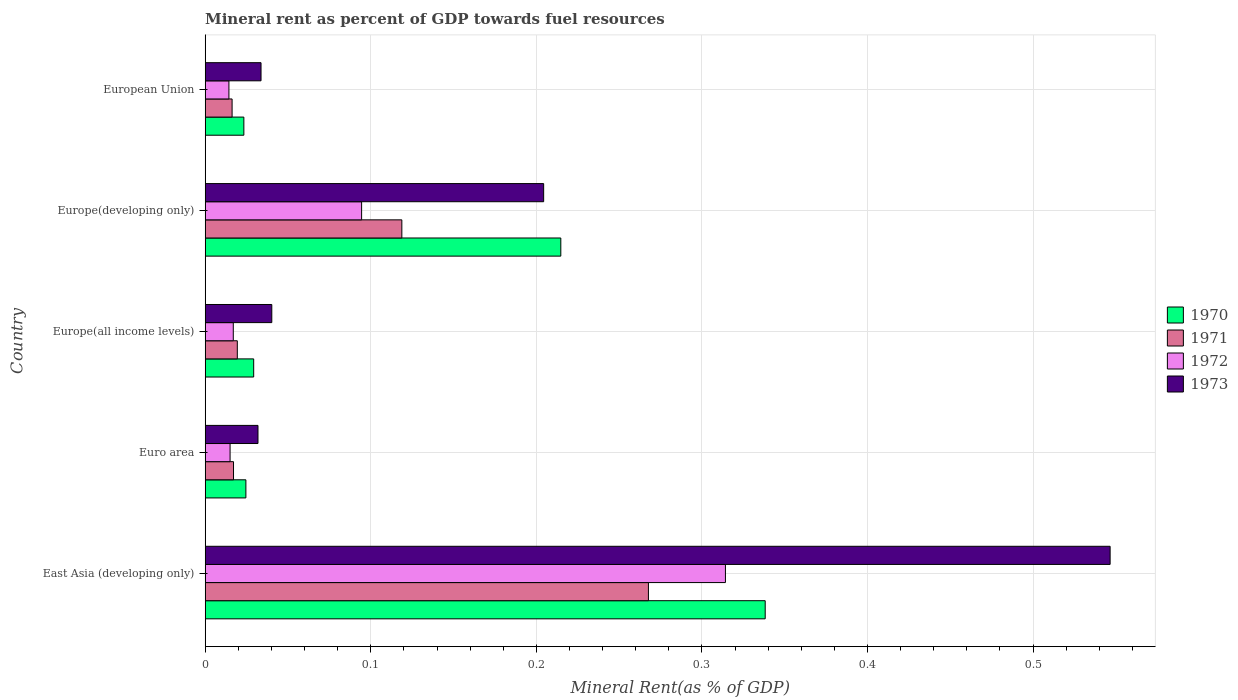How many different coloured bars are there?
Give a very brief answer. 4. Are the number of bars on each tick of the Y-axis equal?
Make the answer very short. Yes. In how many cases, is the number of bars for a given country not equal to the number of legend labels?
Offer a very short reply. 0. What is the mineral rent in 1972 in Europe(all income levels)?
Keep it short and to the point. 0.02. Across all countries, what is the maximum mineral rent in 1971?
Provide a succinct answer. 0.27. Across all countries, what is the minimum mineral rent in 1970?
Offer a very short reply. 0.02. In which country was the mineral rent in 1972 maximum?
Provide a succinct answer. East Asia (developing only). What is the total mineral rent in 1973 in the graph?
Provide a short and direct response. 0.86. What is the difference between the mineral rent in 1973 in Euro area and that in Europe(all income levels)?
Your response must be concise. -0.01. What is the difference between the mineral rent in 1973 in European Union and the mineral rent in 1971 in Europe(all income levels)?
Offer a terse response. 0.01. What is the average mineral rent in 1973 per country?
Give a very brief answer. 0.17. What is the difference between the mineral rent in 1972 and mineral rent in 1973 in European Union?
Keep it short and to the point. -0.02. In how many countries, is the mineral rent in 1972 greater than 0.38000000000000006 %?
Make the answer very short. 0. What is the ratio of the mineral rent in 1973 in Euro area to that in European Union?
Offer a terse response. 0.95. Is the difference between the mineral rent in 1972 in East Asia (developing only) and European Union greater than the difference between the mineral rent in 1973 in East Asia (developing only) and European Union?
Make the answer very short. No. What is the difference between the highest and the second highest mineral rent in 1970?
Your response must be concise. 0.12. What is the difference between the highest and the lowest mineral rent in 1972?
Provide a succinct answer. 0.3. Is the sum of the mineral rent in 1971 in East Asia (developing only) and Europe(developing only) greater than the maximum mineral rent in 1972 across all countries?
Keep it short and to the point. Yes. Is it the case that in every country, the sum of the mineral rent in 1970 and mineral rent in 1971 is greater than the sum of mineral rent in 1973 and mineral rent in 1972?
Ensure brevity in your answer.  No. What does the 2nd bar from the bottom in Europe(all income levels) represents?
Give a very brief answer. 1971. Is it the case that in every country, the sum of the mineral rent in 1970 and mineral rent in 1971 is greater than the mineral rent in 1972?
Give a very brief answer. Yes. How many countries are there in the graph?
Your answer should be very brief. 5. What is the difference between two consecutive major ticks on the X-axis?
Keep it short and to the point. 0.1. Where does the legend appear in the graph?
Your answer should be very brief. Center right. What is the title of the graph?
Ensure brevity in your answer.  Mineral rent as percent of GDP towards fuel resources. What is the label or title of the X-axis?
Offer a terse response. Mineral Rent(as % of GDP). What is the Mineral Rent(as % of GDP) of 1970 in East Asia (developing only)?
Offer a terse response. 0.34. What is the Mineral Rent(as % of GDP) of 1971 in East Asia (developing only)?
Keep it short and to the point. 0.27. What is the Mineral Rent(as % of GDP) of 1972 in East Asia (developing only)?
Offer a very short reply. 0.31. What is the Mineral Rent(as % of GDP) of 1973 in East Asia (developing only)?
Keep it short and to the point. 0.55. What is the Mineral Rent(as % of GDP) of 1970 in Euro area?
Provide a short and direct response. 0.02. What is the Mineral Rent(as % of GDP) in 1971 in Euro area?
Give a very brief answer. 0.02. What is the Mineral Rent(as % of GDP) in 1972 in Euro area?
Provide a succinct answer. 0.02. What is the Mineral Rent(as % of GDP) of 1973 in Euro area?
Ensure brevity in your answer.  0.03. What is the Mineral Rent(as % of GDP) in 1970 in Europe(all income levels)?
Offer a terse response. 0.03. What is the Mineral Rent(as % of GDP) of 1971 in Europe(all income levels)?
Provide a succinct answer. 0.02. What is the Mineral Rent(as % of GDP) in 1972 in Europe(all income levels)?
Provide a short and direct response. 0.02. What is the Mineral Rent(as % of GDP) of 1973 in Europe(all income levels)?
Give a very brief answer. 0.04. What is the Mineral Rent(as % of GDP) of 1970 in Europe(developing only)?
Ensure brevity in your answer.  0.21. What is the Mineral Rent(as % of GDP) in 1971 in Europe(developing only)?
Give a very brief answer. 0.12. What is the Mineral Rent(as % of GDP) of 1972 in Europe(developing only)?
Provide a succinct answer. 0.09. What is the Mineral Rent(as % of GDP) of 1973 in Europe(developing only)?
Your answer should be compact. 0.2. What is the Mineral Rent(as % of GDP) in 1970 in European Union?
Your answer should be compact. 0.02. What is the Mineral Rent(as % of GDP) in 1971 in European Union?
Offer a very short reply. 0.02. What is the Mineral Rent(as % of GDP) in 1972 in European Union?
Provide a short and direct response. 0.01. What is the Mineral Rent(as % of GDP) in 1973 in European Union?
Your answer should be very brief. 0.03. Across all countries, what is the maximum Mineral Rent(as % of GDP) of 1970?
Offer a very short reply. 0.34. Across all countries, what is the maximum Mineral Rent(as % of GDP) of 1971?
Make the answer very short. 0.27. Across all countries, what is the maximum Mineral Rent(as % of GDP) in 1972?
Offer a very short reply. 0.31. Across all countries, what is the maximum Mineral Rent(as % of GDP) of 1973?
Your response must be concise. 0.55. Across all countries, what is the minimum Mineral Rent(as % of GDP) of 1970?
Offer a terse response. 0.02. Across all countries, what is the minimum Mineral Rent(as % of GDP) of 1971?
Keep it short and to the point. 0.02. Across all countries, what is the minimum Mineral Rent(as % of GDP) in 1972?
Provide a succinct answer. 0.01. Across all countries, what is the minimum Mineral Rent(as % of GDP) in 1973?
Give a very brief answer. 0.03. What is the total Mineral Rent(as % of GDP) in 1970 in the graph?
Provide a short and direct response. 0.63. What is the total Mineral Rent(as % of GDP) in 1971 in the graph?
Provide a short and direct response. 0.44. What is the total Mineral Rent(as % of GDP) of 1972 in the graph?
Offer a terse response. 0.46. What is the total Mineral Rent(as % of GDP) of 1973 in the graph?
Your answer should be very brief. 0.86. What is the difference between the Mineral Rent(as % of GDP) in 1970 in East Asia (developing only) and that in Euro area?
Ensure brevity in your answer.  0.31. What is the difference between the Mineral Rent(as % of GDP) of 1971 in East Asia (developing only) and that in Euro area?
Provide a succinct answer. 0.25. What is the difference between the Mineral Rent(as % of GDP) of 1972 in East Asia (developing only) and that in Euro area?
Offer a very short reply. 0.3. What is the difference between the Mineral Rent(as % of GDP) of 1973 in East Asia (developing only) and that in Euro area?
Provide a succinct answer. 0.51. What is the difference between the Mineral Rent(as % of GDP) of 1970 in East Asia (developing only) and that in Europe(all income levels)?
Your response must be concise. 0.31. What is the difference between the Mineral Rent(as % of GDP) of 1971 in East Asia (developing only) and that in Europe(all income levels)?
Give a very brief answer. 0.25. What is the difference between the Mineral Rent(as % of GDP) of 1972 in East Asia (developing only) and that in Europe(all income levels)?
Provide a succinct answer. 0.3. What is the difference between the Mineral Rent(as % of GDP) of 1973 in East Asia (developing only) and that in Europe(all income levels)?
Your answer should be compact. 0.51. What is the difference between the Mineral Rent(as % of GDP) in 1970 in East Asia (developing only) and that in Europe(developing only)?
Your answer should be very brief. 0.12. What is the difference between the Mineral Rent(as % of GDP) in 1971 in East Asia (developing only) and that in Europe(developing only)?
Offer a very short reply. 0.15. What is the difference between the Mineral Rent(as % of GDP) of 1972 in East Asia (developing only) and that in Europe(developing only)?
Make the answer very short. 0.22. What is the difference between the Mineral Rent(as % of GDP) of 1973 in East Asia (developing only) and that in Europe(developing only)?
Provide a succinct answer. 0.34. What is the difference between the Mineral Rent(as % of GDP) in 1970 in East Asia (developing only) and that in European Union?
Your response must be concise. 0.31. What is the difference between the Mineral Rent(as % of GDP) in 1971 in East Asia (developing only) and that in European Union?
Make the answer very short. 0.25. What is the difference between the Mineral Rent(as % of GDP) in 1972 in East Asia (developing only) and that in European Union?
Your answer should be very brief. 0.3. What is the difference between the Mineral Rent(as % of GDP) of 1973 in East Asia (developing only) and that in European Union?
Your answer should be very brief. 0.51. What is the difference between the Mineral Rent(as % of GDP) of 1970 in Euro area and that in Europe(all income levels)?
Your answer should be compact. -0. What is the difference between the Mineral Rent(as % of GDP) in 1971 in Euro area and that in Europe(all income levels)?
Provide a succinct answer. -0. What is the difference between the Mineral Rent(as % of GDP) in 1972 in Euro area and that in Europe(all income levels)?
Offer a very short reply. -0. What is the difference between the Mineral Rent(as % of GDP) in 1973 in Euro area and that in Europe(all income levels)?
Offer a very short reply. -0.01. What is the difference between the Mineral Rent(as % of GDP) of 1970 in Euro area and that in Europe(developing only)?
Your answer should be compact. -0.19. What is the difference between the Mineral Rent(as % of GDP) in 1971 in Euro area and that in Europe(developing only)?
Offer a terse response. -0.1. What is the difference between the Mineral Rent(as % of GDP) in 1972 in Euro area and that in Europe(developing only)?
Keep it short and to the point. -0.08. What is the difference between the Mineral Rent(as % of GDP) in 1973 in Euro area and that in Europe(developing only)?
Keep it short and to the point. -0.17. What is the difference between the Mineral Rent(as % of GDP) in 1970 in Euro area and that in European Union?
Ensure brevity in your answer.  0. What is the difference between the Mineral Rent(as % of GDP) of 1971 in Euro area and that in European Union?
Ensure brevity in your answer.  0. What is the difference between the Mineral Rent(as % of GDP) in 1972 in Euro area and that in European Union?
Make the answer very short. 0. What is the difference between the Mineral Rent(as % of GDP) of 1973 in Euro area and that in European Union?
Make the answer very short. -0. What is the difference between the Mineral Rent(as % of GDP) in 1970 in Europe(all income levels) and that in Europe(developing only)?
Provide a short and direct response. -0.19. What is the difference between the Mineral Rent(as % of GDP) of 1971 in Europe(all income levels) and that in Europe(developing only)?
Your answer should be very brief. -0.1. What is the difference between the Mineral Rent(as % of GDP) of 1972 in Europe(all income levels) and that in Europe(developing only)?
Ensure brevity in your answer.  -0.08. What is the difference between the Mineral Rent(as % of GDP) in 1973 in Europe(all income levels) and that in Europe(developing only)?
Offer a terse response. -0.16. What is the difference between the Mineral Rent(as % of GDP) of 1970 in Europe(all income levels) and that in European Union?
Offer a terse response. 0.01. What is the difference between the Mineral Rent(as % of GDP) in 1971 in Europe(all income levels) and that in European Union?
Make the answer very short. 0. What is the difference between the Mineral Rent(as % of GDP) of 1972 in Europe(all income levels) and that in European Union?
Your answer should be very brief. 0. What is the difference between the Mineral Rent(as % of GDP) in 1973 in Europe(all income levels) and that in European Union?
Provide a succinct answer. 0.01. What is the difference between the Mineral Rent(as % of GDP) in 1970 in Europe(developing only) and that in European Union?
Provide a short and direct response. 0.19. What is the difference between the Mineral Rent(as % of GDP) of 1971 in Europe(developing only) and that in European Union?
Provide a succinct answer. 0.1. What is the difference between the Mineral Rent(as % of GDP) in 1972 in Europe(developing only) and that in European Union?
Your answer should be very brief. 0.08. What is the difference between the Mineral Rent(as % of GDP) in 1973 in Europe(developing only) and that in European Union?
Ensure brevity in your answer.  0.17. What is the difference between the Mineral Rent(as % of GDP) in 1970 in East Asia (developing only) and the Mineral Rent(as % of GDP) in 1971 in Euro area?
Provide a succinct answer. 0.32. What is the difference between the Mineral Rent(as % of GDP) of 1970 in East Asia (developing only) and the Mineral Rent(as % of GDP) of 1972 in Euro area?
Keep it short and to the point. 0.32. What is the difference between the Mineral Rent(as % of GDP) in 1970 in East Asia (developing only) and the Mineral Rent(as % of GDP) in 1973 in Euro area?
Make the answer very short. 0.31. What is the difference between the Mineral Rent(as % of GDP) of 1971 in East Asia (developing only) and the Mineral Rent(as % of GDP) of 1972 in Euro area?
Provide a short and direct response. 0.25. What is the difference between the Mineral Rent(as % of GDP) in 1971 in East Asia (developing only) and the Mineral Rent(as % of GDP) in 1973 in Euro area?
Provide a succinct answer. 0.24. What is the difference between the Mineral Rent(as % of GDP) of 1972 in East Asia (developing only) and the Mineral Rent(as % of GDP) of 1973 in Euro area?
Provide a short and direct response. 0.28. What is the difference between the Mineral Rent(as % of GDP) of 1970 in East Asia (developing only) and the Mineral Rent(as % of GDP) of 1971 in Europe(all income levels)?
Your response must be concise. 0.32. What is the difference between the Mineral Rent(as % of GDP) in 1970 in East Asia (developing only) and the Mineral Rent(as % of GDP) in 1972 in Europe(all income levels)?
Offer a very short reply. 0.32. What is the difference between the Mineral Rent(as % of GDP) of 1970 in East Asia (developing only) and the Mineral Rent(as % of GDP) of 1973 in Europe(all income levels)?
Ensure brevity in your answer.  0.3. What is the difference between the Mineral Rent(as % of GDP) of 1971 in East Asia (developing only) and the Mineral Rent(as % of GDP) of 1972 in Europe(all income levels)?
Give a very brief answer. 0.25. What is the difference between the Mineral Rent(as % of GDP) of 1971 in East Asia (developing only) and the Mineral Rent(as % of GDP) of 1973 in Europe(all income levels)?
Make the answer very short. 0.23. What is the difference between the Mineral Rent(as % of GDP) of 1972 in East Asia (developing only) and the Mineral Rent(as % of GDP) of 1973 in Europe(all income levels)?
Give a very brief answer. 0.27. What is the difference between the Mineral Rent(as % of GDP) in 1970 in East Asia (developing only) and the Mineral Rent(as % of GDP) in 1971 in Europe(developing only)?
Your answer should be compact. 0.22. What is the difference between the Mineral Rent(as % of GDP) in 1970 in East Asia (developing only) and the Mineral Rent(as % of GDP) in 1972 in Europe(developing only)?
Give a very brief answer. 0.24. What is the difference between the Mineral Rent(as % of GDP) of 1970 in East Asia (developing only) and the Mineral Rent(as % of GDP) of 1973 in Europe(developing only)?
Your answer should be very brief. 0.13. What is the difference between the Mineral Rent(as % of GDP) of 1971 in East Asia (developing only) and the Mineral Rent(as % of GDP) of 1972 in Europe(developing only)?
Provide a short and direct response. 0.17. What is the difference between the Mineral Rent(as % of GDP) of 1971 in East Asia (developing only) and the Mineral Rent(as % of GDP) of 1973 in Europe(developing only)?
Make the answer very short. 0.06. What is the difference between the Mineral Rent(as % of GDP) of 1972 in East Asia (developing only) and the Mineral Rent(as % of GDP) of 1973 in Europe(developing only)?
Offer a very short reply. 0.11. What is the difference between the Mineral Rent(as % of GDP) of 1970 in East Asia (developing only) and the Mineral Rent(as % of GDP) of 1971 in European Union?
Your answer should be very brief. 0.32. What is the difference between the Mineral Rent(as % of GDP) of 1970 in East Asia (developing only) and the Mineral Rent(as % of GDP) of 1972 in European Union?
Provide a succinct answer. 0.32. What is the difference between the Mineral Rent(as % of GDP) in 1970 in East Asia (developing only) and the Mineral Rent(as % of GDP) in 1973 in European Union?
Offer a terse response. 0.3. What is the difference between the Mineral Rent(as % of GDP) in 1971 in East Asia (developing only) and the Mineral Rent(as % of GDP) in 1972 in European Union?
Provide a short and direct response. 0.25. What is the difference between the Mineral Rent(as % of GDP) in 1971 in East Asia (developing only) and the Mineral Rent(as % of GDP) in 1973 in European Union?
Ensure brevity in your answer.  0.23. What is the difference between the Mineral Rent(as % of GDP) of 1972 in East Asia (developing only) and the Mineral Rent(as % of GDP) of 1973 in European Union?
Make the answer very short. 0.28. What is the difference between the Mineral Rent(as % of GDP) of 1970 in Euro area and the Mineral Rent(as % of GDP) of 1971 in Europe(all income levels)?
Offer a very short reply. 0.01. What is the difference between the Mineral Rent(as % of GDP) in 1970 in Euro area and the Mineral Rent(as % of GDP) in 1972 in Europe(all income levels)?
Give a very brief answer. 0.01. What is the difference between the Mineral Rent(as % of GDP) of 1970 in Euro area and the Mineral Rent(as % of GDP) of 1973 in Europe(all income levels)?
Provide a succinct answer. -0.02. What is the difference between the Mineral Rent(as % of GDP) of 1971 in Euro area and the Mineral Rent(as % of GDP) of 1972 in Europe(all income levels)?
Provide a short and direct response. 0. What is the difference between the Mineral Rent(as % of GDP) in 1971 in Euro area and the Mineral Rent(as % of GDP) in 1973 in Europe(all income levels)?
Provide a succinct answer. -0.02. What is the difference between the Mineral Rent(as % of GDP) in 1972 in Euro area and the Mineral Rent(as % of GDP) in 1973 in Europe(all income levels)?
Give a very brief answer. -0.03. What is the difference between the Mineral Rent(as % of GDP) in 1970 in Euro area and the Mineral Rent(as % of GDP) in 1971 in Europe(developing only)?
Offer a very short reply. -0.09. What is the difference between the Mineral Rent(as % of GDP) in 1970 in Euro area and the Mineral Rent(as % of GDP) in 1972 in Europe(developing only)?
Offer a terse response. -0.07. What is the difference between the Mineral Rent(as % of GDP) of 1970 in Euro area and the Mineral Rent(as % of GDP) of 1973 in Europe(developing only)?
Provide a succinct answer. -0.18. What is the difference between the Mineral Rent(as % of GDP) in 1971 in Euro area and the Mineral Rent(as % of GDP) in 1972 in Europe(developing only)?
Provide a succinct answer. -0.08. What is the difference between the Mineral Rent(as % of GDP) of 1971 in Euro area and the Mineral Rent(as % of GDP) of 1973 in Europe(developing only)?
Offer a very short reply. -0.19. What is the difference between the Mineral Rent(as % of GDP) of 1972 in Euro area and the Mineral Rent(as % of GDP) of 1973 in Europe(developing only)?
Offer a terse response. -0.19. What is the difference between the Mineral Rent(as % of GDP) of 1970 in Euro area and the Mineral Rent(as % of GDP) of 1971 in European Union?
Your response must be concise. 0.01. What is the difference between the Mineral Rent(as % of GDP) in 1970 in Euro area and the Mineral Rent(as % of GDP) in 1972 in European Union?
Your answer should be compact. 0.01. What is the difference between the Mineral Rent(as % of GDP) in 1970 in Euro area and the Mineral Rent(as % of GDP) in 1973 in European Union?
Offer a terse response. -0.01. What is the difference between the Mineral Rent(as % of GDP) in 1971 in Euro area and the Mineral Rent(as % of GDP) in 1972 in European Union?
Offer a terse response. 0. What is the difference between the Mineral Rent(as % of GDP) of 1971 in Euro area and the Mineral Rent(as % of GDP) of 1973 in European Union?
Your response must be concise. -0.02. What is the difference between the Mineral Rent(as % of GDP) of 1972 in Euro area and the Mineral Rent(as % of GDP) of 1973 in European Union?
Ensure brevity in your answer.  -0.02. What is the difference between the Mineral Rent(as % of GDP) in 1970 in Europe(all income levels) and the Mineral Rent(as % of GDP) in 1971 in Europe(developing only)?
Your answer should be compact. -0.09. What is the difference between the Mineral Rent(as % of GDP) of 1970 in Europe(all income levels) and the Mineral Rent(as % of GDP) of 1972 in Europe(developing only)?
Provide a short and direct response. -0.07. What is the difference between the Mineral Rent(as % of GDP) of 1970 in Europe(all income levels) and the Mineral Rent(as % of GDP) of 1973 in Europe(developing only)?
Make the answer very short. -0.18. What is the difference between the Mineral Rent(as % of GDP) in 1971 in Europe(all income levels) and the Mineral Rent(as % of GDP) in 1972 in Europe(developing only)?
Your answer should be very brief. -0.08. What is the difference between the Mineral Rent(as % of GDP) of 1971 in Europe(all income levels) and the Mineral Rent(as % of GDP) of 1973 in Europe(developing only)?
Your answer should be very brief. -0.18. What is the difference between the Mineral Rent(as % of GDP) in 1972 in Europe(all income levels) and the Mineral Rent(as % of GDP) in 1973 in Europe(developing only)?
Give a very brief answer. -0.19. What is the difference between the Mineral Rent(as % of GDP) of 1970 in Europe(all income levels) and the Mineral Rent(as % of GDP) of 1971 in European Union?
Offer a terse response. 0.01. What is the difference between the Mineral Rent(as % of GDP) in 1970 in Europe(all income levels) and the Mineral Rent(as % of GDP) in 1972 in European Union?
Your response must be concise. 0.01. What is the difference between the Mineral Rent(as % of GDP) of 1970 in Europe(all income levels) and the Mineral Rent(as % of GDP) of 1973 in European Union?
Give a very brief answer. -0. What is the difference between the Mineral Rent(as % of GDP) of 1971 in Europe(all income levels) and the Mineral Rent(as % of GDP) of 1972 in European Union?
Offer a very short reply. 0.01. What is the difference between the Mineral Rent(as % of GDP) in 1971 in Europe(all income levels) and the Mineral Rent(as % of GDP) in 1973 in European Union?
Make the answer very short. -0.01. What is the difference between the Mineral Rent(as % of GDP) of 1972 in Europe(all income levels) and the Mineral Rent(as % of GDP) of 1973 in European Union?
Ensure brevity in your answer.  -0.02. What is the difference between the Mineral Rent(as % of GDP) in 1970 in Europe(developing only) and the Mineral Rent(as % of GDP) in 1971 in European Union?
Offer a terse response. 0.2. What is the difference between the Mineral Rent(as % of GDP) of 1970 in Europe(developing only) and the Mineral Rent(as % of GDP) of 1972 in European Union?
Give a very brief answer. 0.2. What is the difference between the Mineral Rent(as % of GDP) in 1970 in Europe(developing only) and the Mineral Rent(as % of GDP) in 1973 in European Union?
Make the answer very short. 0.18. What is the difference between the Mineral Rent(as % of GDP) in 1971 in Europe(developing only) and the Mineral Rent(as % of GDP) in 1972 in European Union?
Make the answer very short. 0.1. What is the difference between the Mineral Rent(as % of GDP) in 1971 in Europe(developing only) and the Mineral Rent(as % of GDP) in 1973 in European Union?
Your response must be concise. 0.09. What is the difference between the Mineral Rent(as % of GDP) in 1972 in Europe(developing only) and the Mineral Rent(as % of GDP) in 1973 in European Union?
Make the answer very short. 0.06. What is the average Mineral Rent(as % of GDP) of 1970 per country?
Offer a very short reply. 0.13. What is the average Mineral Rent(as % of GDP) of 1971 per country?
Ensure brevity in your answer.  0.09. What is the average Mineral Rent(as % of GDP) in 1972 per country?
Offer a terse response. 0.09. What is the average Mineral Rent(as % of GDP) in 1973 per country?
Give a very brief answer. 0.17. What is the difference between the Mineral Rent(as % of GDP) in 1970 and Mineral Rent(as % of GDP) in 1971 in East Asia (developing only)?
Offer a very short reply. 0.07. What is the difference between the Mineral Rent(as % of GDP) of 1970 and Mineral Rent(as % of GDP) of 1972 in East Asia (developing only)?
Give a very brief answer. 0.02. What is the difference between the Mineral Rent(as % of GDP) in 1970 and Mineral Rent(as % of GDP) in 1973 in East Asia (developing only)?
Offer a terse response. -0.21. What is the difference between the Mineral Rent(as % of GDP) in 1971 and Mineral Rent(as % of GDP) in 1972 in East Asia (developing only)?
Offer a very short reply. -0.05. What is the difference between the Mineral Rent(as % of GDP) of 1971 and Mineral Rent(as % of GDP) of 1973 in East Asia (developing only)?
Your answer should be compact. -0.28. What is the difference between the Mineral Rent(as % of GDP) in 1972 and Mineral Rent(as % of GDP) in 1973 in East Asia (developing only)?
Give a very brief answer. -0.23. What is the difference between the Mineral Rent(as % of GDP) in 1970 and Mineral Rent(as % of GDP) in 1971 in Euro area?
Offer a very short reply. 0.01. What is the difference between the Mineral Rent(as % of GDP) in 1970 and Mineral Rent(as % of GDP) in 1972 in Euro area?
Your answer should be compact. 0.01. What is the difference between the Mineral Rent(as % of GDP) in 1970 and Mineral Rent(as % of GDP) in 1973 in Euro area?
Provide a succinct answer. -0.01. What is the difference between the Mineral Rent(as % of GDP) in 1971 and Mineral Rent(as % of GDP) in 1972 in Euro area?
Provide a succinct answer. 0. What is the difference between the Mineral Rent(as % of GDP) in 1971 and Mineral Rent(as % of GDP) in 1973 in Euro area?
Your answer should be very brief. -0.01. What is the difference between the Mineral Rent(as % of GDP) of 1972 and Mineral Rent(as % of GDP) of 1973 in Euro area?
Ensure brevity in your answer.  -0.02. What is the difference between the Mineral Rent(as % of GDP) in 1970 and Mineral Rent(as % of GDP) in 1971 in Europe(all income levels)?
Your answer should be compact. 0.01. What is the difference between the Mineral Rent(as % of GDP) in 1970 and Mineral Rent(as % of GDP) in 1972 in Europe(all income levels)?
Provide a short and direct response. 0.01. What is the difference between the Mineral Rent(as % of GDP) of 1970 and Mineral Rent(as % of GDP) of 1973 in Europe(all income levels)?
Provide a short and direct response. -0.01. What is the difference between the Mineral Rent(as % of GDP) in 1971 and Mineral Rent(as % of GDP) in 1972 in Europe(all income levels)?
Keep it short and to the point. 0. What is the difference between the Mineral Rent(as % of GDP) in 1971 and Mineral Rent(as % of GDP) in 1973 in Europe(all income levels)?
Make the answer very short. -0.02. What is the difference between the Mineral Rent(as % of GDP) in 1972 and Mineral Rent(as % of GDP) in 1973 in Europe(all income levels)?
Provide a short and direct response. -0.02. What is the difference between the Mineral Rent(as % of GDP) of 1970 and Mineral Rent(as % of GDP) of 1971 in Europe(developing only)?
Offer a terse response. 0.1. What is the difference between the Mineral Rent(as % of GDP) in 1970 and Mineral Rent(as % of GDP) in 1972 in Europe(developing only)?
Your response must be concise. 0.12. What is the difference between the Mineral Rent(as % of GDP) in 1970 and Mineral Rent(as % of GDP) in 1973 in Europe(developing only)?
Offer a very short reply. 0.01. What is the difference between the Mineral Rent(as % of GDP) of 1971 and Mineral Rent(as % of GDP) of 1972 in Europe(developing only)?
Provide a short and direct response. 0.02. What is the difference between the Mineral Rent(as % of GDP) of 1971 and Mineral Rent(as % of GDP) of 1973 in Europe(developing only)?
Make the answer very short. -0.09. What is the difference between the Mineral Rent(as % of GDP) in 1972 and Mineral Rent(as % of GDP) in 1973 in Europe(developing only)?
Provide a short and direct response. -0.11. What is the difference between the Mineral Rent(as % of GDP) of 1970 and Mineral Rent(as % of GDP) of 1971 in European Union?
Offer a terse response. 0.01. What is the difference between the Mineral Rent(as % of GDP) of 1970 and Mineral Rent(as % of GDP) of 1972 in European Union?
Your answer should be compact. 0.01. What is the difference between the Mineral Rent(as % of GDP) in 1970 and Mineral Rent(as % of GDP) in 1973 in European Union?
Ensure brevity in your answer.  -0.01. What is the difference between the Mineral Rent(as % of GDP) in 1971 and Mineral Rent(as % of GDP) in 1972 in European Union?
Offer a very short reply. 0. What is the difference between the Mineral Rent(as % of GDP) in 1971 and Mineral Rent(as % of GDP) in 1973 in European Union?
Give a very brief answer. -0.02. What is the difference between the Mineral Rent(as % of GDP) in 1972 and Mineral Rent(as % of GDP) in 1973 in European Union?
Ensure brevity in your answer.  -0.02. What is the ratio of the Mineral Rent(as % of GDP) in 1970 in East Asia (developing only) to that in Euro area?
Make the answer very short. 13.76. What is the ratio of the Mineral Rent(as % of GDP) of 1971 in East Asia (developing only) to that in Euro area?
Your answer should be very brief. 15.65. What is the ratio of the Mineral Rent(as % of GDP) of 1972 in East Asia (developing only) to that in Euro area?
Your response must be concise. 20.91. What is the ratio of the Mineral Rent(as % of GDP) in 1973 in East Asia (developing only) to that in Euro area?
Your response must be concise. 17.14. What is the ratio of the Mineral Rent(as % of GDP) of 1970 in East Asia (developing only) to that in Europe(all income levels)?
Your answer should be compact. 11.55. What is the ratio of the Mineral Rent(as % of GDP) in 1971 in East Asia (developing only) to that in Europe(all income levels)?
Your answer should be very brief. 13.8. What is the ratio of the Mineral Rent(as % of GDP) of 1972 in East Asia (developing only) to that in Europe(all income levels)?
Your answer should be compact. 18.52. What is the ratio of the Mineral Rent(as % of GDP) of 1973 in East Asia (developing only) to that in Europe(all income levels)?
Your answer should be very brief. 13.59. What is the ratio of the Mineral Rent(as % of GDP) of 1970 in East Asia (developing only) to that in Europe(developing only)?
Offer a terse response. 1.57. What is the ratio of the Mineral Rent(as % of GDP) of 1971 in East Asia (developing only) to that in Europe(developing only)?
Provide a succinct answer. 2.25. What is the ratio of the Mineral Rent(as % of GDP) of 1972 in East Asia (developing only) to that in Europe(developing only)?
Ensure brevity in your answer.  3.33. What is the ratio of the Mineral Rent(as % of GDP) in 1973 in East Asia (developing only) to that in Europe(developing only)?
Your answer should be compact. 2.67. What is the ratio of the Mineral Rent(as % of GDP) in 1970 in East Asia (developing only) to that in European Union?
Provide a short and direct response. 14.48. What is the ratio of the Mineral Rent(as % of GDP) in 1971 in East Asia (developing only) to that in European Union?
Ensure brevity in your answer.  16.48. What is the ratio of the Mineral Rent(as % of GDP) of 1972 in East Asia (developing only) to that in European Union?
Your answer should be very brief. 21.92. What is the ratio of the Mineral Rent(as % of GDP) of 1973 in East Asia (developing only) to that in European Union?
Ensure brevity in your answer.  16.21. What is the ratio of the Mineral Rent(as % of GDP) in 1970 in Euro area to that in Europe(all income levels)?
Give a very brief answer. 0.84. What is the ratio of the Mineral Rent(as % of GDP) in 1971 in Euro area to that in Europe(all income levels)?
Your response must be concise. 0.88. What is the ratio of the Mineral Rent(as % of GDP) in 1972 in Euro area to that in Europe(all income levels)?
Make the answer very short. 0.89. What is the ratio of the Mineral Rent(as % of GDP) of 1973 in Euro area to that in Europe(all income levels)?
Your answer should be very brief. 0.79. What is the ratio of the Mineral Rent(as % of GDP) of 1970 in Euro area to that in Europe(developing only)?
Your response must be concise. 0.11. What is the ratio of the Mineral Rent(as % of GDP) of 1971 in Euro area to that in Europe(developing only)?
Your answer should be very brief. 0.14. What is the ratio of the Mineral Rent(as % of GDP) in 1972 in Euro area to that in Europe(developing only)?
Provide a short and direct response. 0.16. What is the ratio of the Mineral Rent(as % of GDP) of 1973 in Euro area to that in Europe(developing only)?
Provide a short and direct response. 0.16. What is the ratio of the Mineral Rent(as % of GDP) of 1970 in Euro area to that in European Union?
Provide a succinct answer. 1.05. What is the ratio of the Mineral Rent(as % of GDP) in 1971 in Euro area to that in European Union?
Offer a very short reply. 1.05. What is the ratio of the Mineral Rent(as % of GDP) in 1972 in Euro area to that in European Union?
Provide a succinct answer. 1.05. What is the ratio of the Mineral Rent(as % of GDP) of 1973 in Euro area to that in European Union?
Keep it short and to the point. 0.95. What is the ratio of the Mineral Rent(as % of GDP) in 1970 in Europe(all income levels) to that in Europe(developing only)?
Your response must be concise. 0.14. What is the ratio of the Mineral Rent(as % of GDP) of 1971 in Europe(all income levels) to that in Europe(developing only)?
Provide a succinct answer. 0.16. What is the ratio of the Mineral Rent(as % of GDP) in 1972 in Europe(all income levels) to that in Europe(developing only)?
Make the answer very short. 0.18. What is the ratio of the Mineral Rent(as % of GDP) of 1973 in Europe(all income levels) to that in Europe(developing only)?
Your answer should be compact. 0.2. What is the ratio of the Mineral Rent(as % of GDP) of 1970 in Europe(all income levels) to that in European Union?
Your answer should be compact. 1.25. What is the ratio of the Mineral Rent(as % of GDP) in 1971 in Europe(all income levels) to that in European Union?
Offer a terse response. 1.19. What is the ratio of the Mineral Rent(as % of GDP) in 1972 in Europe(all income levels) to that in European Union?
Provide a short and direct response. 1.18. What is the ratio of the Mineral Rent(as % of GDP) in 1973 in Europe(all income levels) to that in European Union?
Provide a short and direct response. 1.19. What is the ratio of the Mineral Rent(as % of GDP) of 1970 in Europe(developing only) to that in European Union?
Keep it short and to the point. 9.2. What is the ratio of the Mineral Rent(as % of GDP) of 1971 in Europe(developing only) to that in European Union?
Provide a short and direct response. 7.31. What is the ratio of the Mineral Rent(as % of GDP) in 1972 in Europe(developing only) to that in European Union?
Offer a terse response. 6.59. What is the ratio of the Mineral Rent(as % of GDP) of 1973 in Europe(developing only) to that in European Union?
Your response must be concise. 6.06. What is the difference between the highest and the second highest Mineral Rent(as % of GDP) of 1970?
Keep it short and to the point. 0.12. What is the difference between the highest and the second highest Mineral Rent(as % of GDP) in 1971?
Make the answer very short. 0.15. What is the difference between the highest and the second highest Mineral Rent(as % of GDP) of 1972?
Your answer should be compact. 0.22. What is the difference between the highest and the second highest Mineral Rent(as % of GDP) in 1973?
Your answer should be very brief. 0.34. What is the difference between the highest and the lowest Mineral Rent(as % of GDP) in 1970?
Make the answer very short. 0.31. What is the difference between the highest and the lowest Mineral Rent(as % of GDP) of 1971?
Provide a short and direct response. 0.25. What is the difference between the highest and the lowest Mineral Rent(as % of GDP) of 1972?
Your answer should be compact. 0.3. What is the difference between the highest and the lowest Mineral Rent(as % of GDP) in 1973?
Provide a short and direct response. 0.51. 